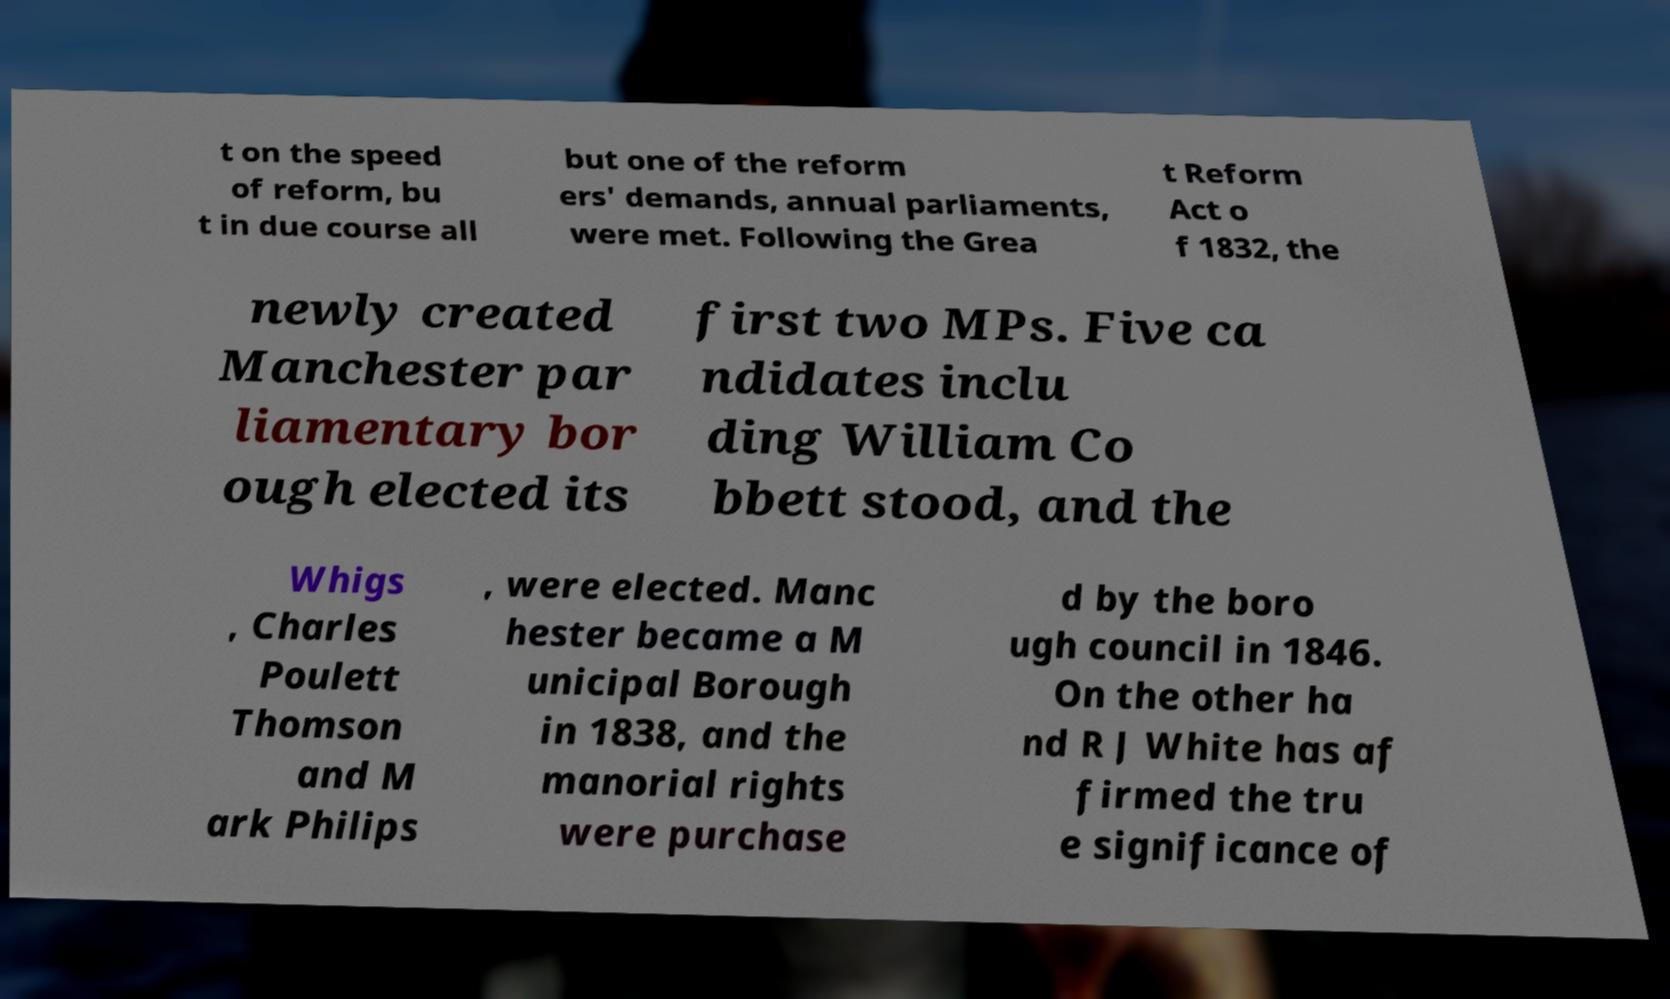For documentation purposes, I need the text within this image transcribed. Could you provide that? t on the speed of reform, bu t in due course all but one of the reform ers' demands, annual parliaments, were met. Following the Grea t Reform Act o f 1832, the newly created Manchester par liamentary bor ough elected its first two MPs. Five ca ndidates inclu ding William Co bbett stood, and the Whigs , Charles Poulett Thomson and M ark Philips , were elected. Manc hester became a M unicipal Borough in 1838, and the manorial rights were purchase d by the boro ugh council in 1846. On the other ha nd R J White has af firmed the tru e significance of 